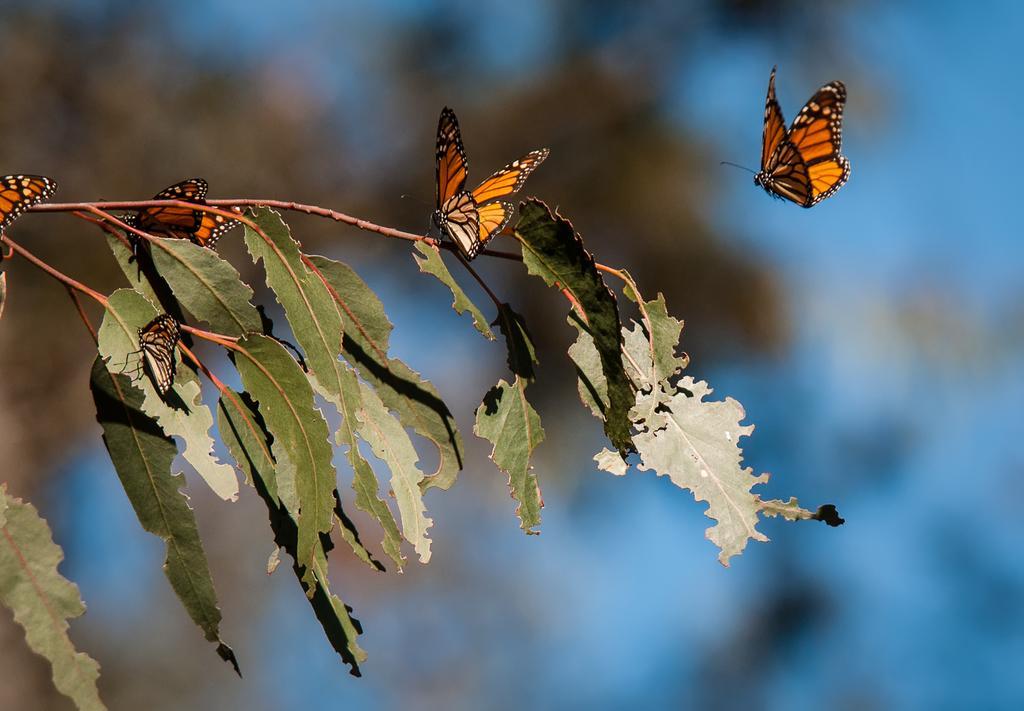Can you describe this image briefly? In this picture I can see few butterflies on the branch and I can see leaves and looks like a tree in the background. 